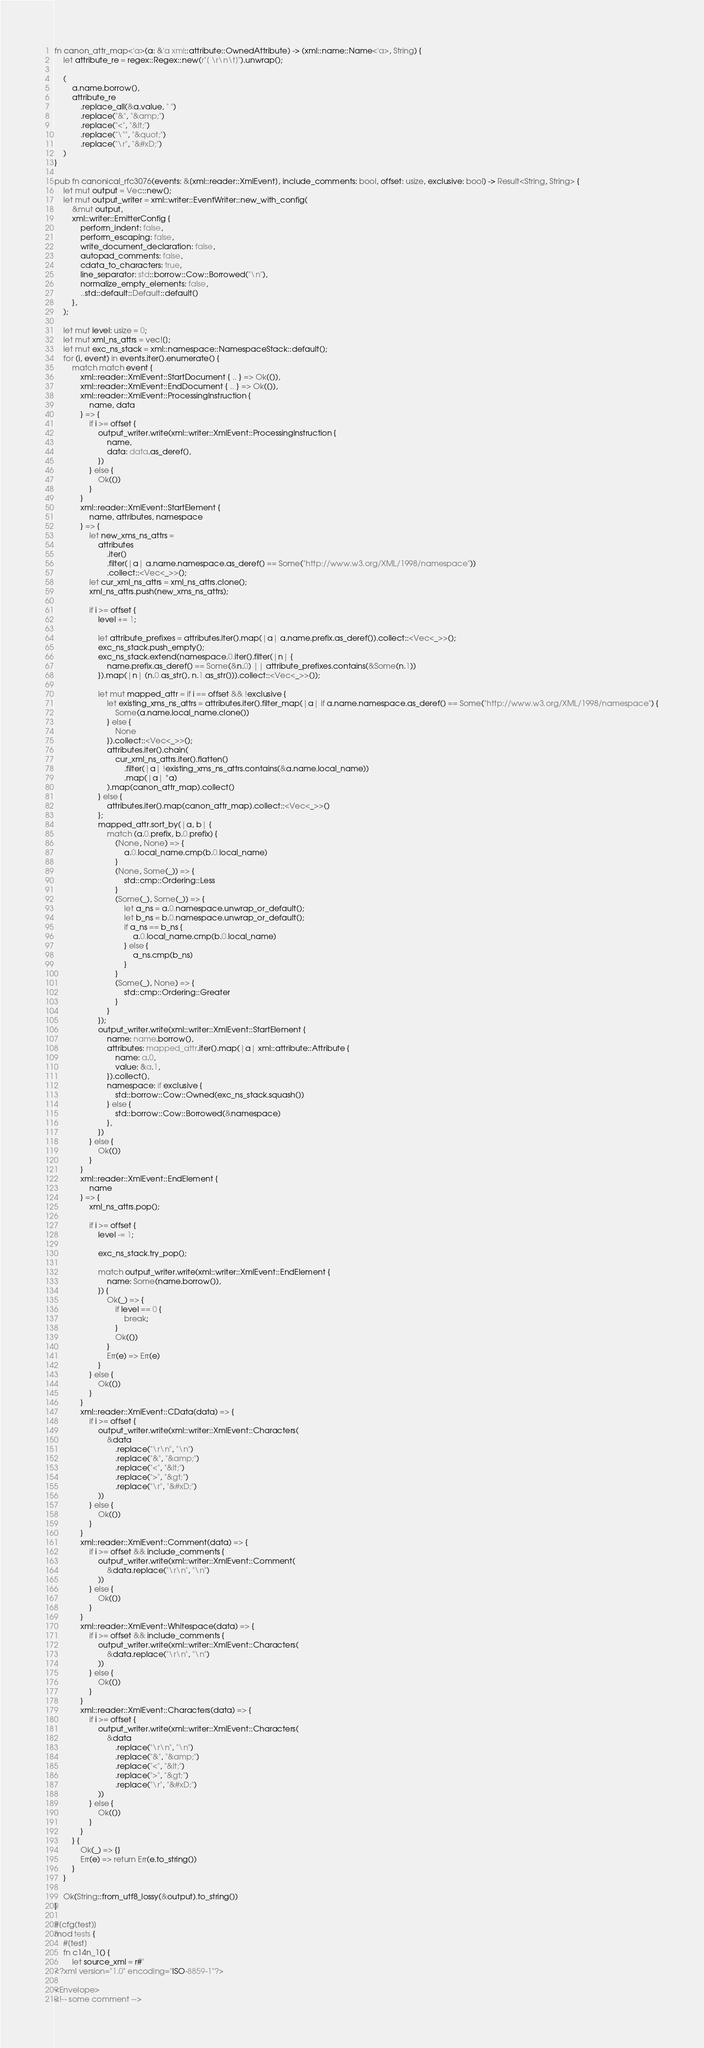Convert code to text. <code><loc_0><loc_0><loc_500><loc_500><_Rust_>fn canon_attr_map<'a>(a: &'a xml::attribute::OwnedAttribute) -> (xml::name::Name<'a>, String) {
    let attribute_re = regex::Regex::new(r"[ \r\n\t]").unwrap();

    (
        a.name.borrow(),
        attribute_re
            .replace_all(&a.value, " ")
            .replace("&", "&amp;")
            .replace("<", "&lt;")
            .replace("\"", "&quot;")
            .replace("\r", "&#xD;")
    )
}

pub fn canonical_rfc3076(events: &[xml::reader::XmlEvent], include_comments: bool, offset: usize, exclusive: bool) -> Result<String, String> {
    let mut output = Vec::new();
    let mut output_writer = xml::writer::EventWriter::new_with_config(
        &mut output,
        xml::writer::EmitterConfig {
            perform_indent: false,
            perform_escaping: false,
            write_document_declaration: false,
            autopad_comments: false,
            cdata_to_characters: true,
            line_separator: std::borrow::Cow::Borrowed("\n"),
            normalize_empty_elements: false,
            ..std::default::Default::default()
        },
    );

    let mut level: usize = 0;
    let mut xml_ns_attrs = vec![];
    let mut exc_ns_stack = xml::namespace::NamespaceStack::default();
    for (i, event) in events.iter().enumerate() {
        match match event {
            xml::reader::XmlEvent::StartDocument { .. } => Ok(()),
            xml::reader::XmlEvent::EndDocument { .. } => Ok(()),
            xml::reader::XmlEvent::ProcessingInstruction {
                name, data
            } => {
                if i >= offset {
                    output_writer.write(xml::writer::XmlEvent::ProcessingInstruction {
                        name,
                        data: data.as_deref(),
                    })
                } else {
                    Ok(())
                }
            }
            xml::reader::XmlEvent::StartElement {
                name, attributes, namespace
            } => {
                let new_xms_ns_attrs =
                    attributes
                        .iter()
                        .filter(|a| a.name.namespace.as_deref() == Some("http://www.w3.org/XML/1998/namespace"))
                        .collect::<Vec<_>>();
                let cur_xml_ns_attrs = xml_ns_attrs.clone();
                xml_ns_attrs.push(new_xms_ns_attrs);

                if i >= offset {
                    level += 1;

                    let attribute_prefixes = attributes.iter().map(|a| a.name.prefix.as_deref()).collect::<Vec<_>>();
                    exc_ns_stack.push_empty();
                    exc_ns_stack.extend(namespace.0.iter().filter(|n| {
                        name.prefix.as_deref() == Some(&n.0) || attribute_prefixes.contains(&Some(n.1))
                    }).map(|n| (n.0.as_str(), n.1.as_str())).collect::<Vec<_>>());

                    let mut mapped_attr = if i == offset && !exclusive {
                        let existing_xms_ns_attrs = attributes.iter().filter_map(|a| if a.name.namespace.as_deref() == Some("http://www.w3.org/XML/1998/namespace") {
                            Some(a.name.local_name.clone())
                        } else {
                            None
                        }).collect::<Vec<_>>();
                        attributes.iter().chain(
                            cur_xml_ns_attrs.iter().flatten()
                                .filter(|a| !existing_xms_ns_attrs.contains(&a.name.local_name))
                                .map(|a| *a)
                        ).map(canon_attr_map).collect()
                    } else {
                        attributes.iter().map(canon_attr_map).collect::<Vec<_>>()
                    };
                    mapped_attr.sort_by(|a, b| {
                        match (a.0.prefix, b.0.prefix) {
                            (None, None) => {
                                a.0.local_name.cmp(b.0.local_name)
                            }
                            (None, Some(_)) => {
                                std::cmp::Ordering::Less
                            }
                            (Some(_), Some(_)) => {
                                let a_ns = a.0.namespace.unwrap_or_default();
                                let b_ns = b.0.namespace.unwrap_or_default();
                                if a_ns == b_ns {
                                    a.0.local_name.cmp(b.0.local_name)
                                } else {
                                    a_ns.cmp(b_ns)
                                }
                            }
                            (Some(_), None) => {
                                std::cmp::Ordering::Greater
                            }
                        }
                    });
                    output_writer.write(xml::writer::XmlEvent::StartElement {
                        name: name.borrow(),
                        attributes: mapped_attr.iter().map(|a| xml::attribute::Attribute {
                            name: a.0,
                            value: &a.1,
                        }).collect(),
                        namespace: if exclusive {
                            std::borrow::Cow::Owned(exc_ns_stack.squash())
                        } else {
                            std::borrow::Cow::Borrowed(&namespace)
                        },
                    })
                } else {
                    Ok(())
                }
            }
            xml::reader::XmlEvent::EndElement {
                name
            } => {
                xml_ns_attrs.pop();

                if i >= offset {
                    level -= 1;

                    exc_ns_stack.try_pop();

                    match output_writer.write(xml::writer::XmlEvent::EndElement {
                        name: Some(name.borrow()),
                    }) {
                        Ok(_) => {
                            if level == 0 {
                                break;
                            }
                            Ok(())
                        }
                        Err(e) => Err(e)
                    }
                } else {
                    Ok(())
                }
            }
            xml::reader::XmlEvent::CData(data) => {
                if i >= offset {
                    output_writer.write(xml::writer::XmlEvent::Characters(
                        &data
                            .replace("\r\n", "\n")
                            .replace("&", "&amp;")
                            .replace("<", "&lt;")
                            .replace(">", "&gt;")
                            .replace("\r", "&#xD;")
                    ))
                } else {
                    Ok(())
                }
            }
            xml::reader::XmlEvent::Comment(data) => {
                if i >= offset && include_comments {
                    output_writer.write(xml::writer::XmlEvent::Comment(
                        &data.replace("\r\n", "\n")
                    ))
                } else {
                    Ok(())
                }
            }
            xml::reader::XmlEvent::Whitespace(data) => {
                if i >= offset && include_comments {
                    output_writer.write(xml::writer::XmlEvent::Characters(
                        &data.replace("\r\n", "\n")
                    ))
                } else {
                    Ok(())
                }
            }
            xml::reader::XmlEvent::Characters(data) => {
                if i >= offset {
                    output_writer.write(xml::writer::XmlEvent::Characters(
                        &data
                            .replace("\r\n", "\n")
                            .replace("&", "&amp;")
                            .replace("<", "&lt;")
                            .replace(">", "&gt;")
                            .replace("\r", "&#xD;")
                    ))
                } else {
                    Ok(())
                }
            }
        } {
            Ok(_) => {}
            Err(e) => return Err(e.to_string())
        }
    }

    Ok(String::from_utf8_lossy(&output).to_string())
}

#[cfg(test)]
mod tests {
    #[test]
    fn c14n_1() {
        let source_xml = r#"
<?xml version="1.0" encoding="ISO-8859-1"?>

<Envelope>
<!-- some comment --></code> 